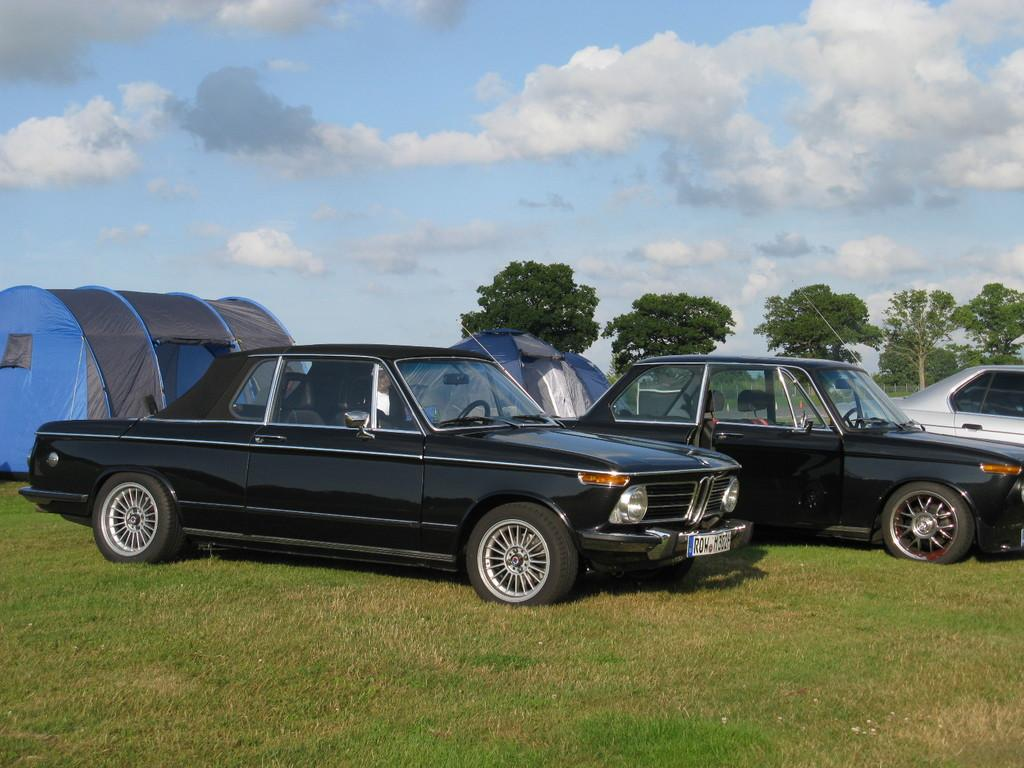How many cars are present in the image? There are three cars in the image. What other structures can be seen in the image besides the cars? There are two tents in the image. What type of natural environment is visible in the background of the image? There are trees in the background of the image. What is visible at the top of the image? The sky is visible at the top of the image. What flavor of ice cream is being served in the image? There is no ice cream present in the image; it only features cars, tents, trees, and the sky. 